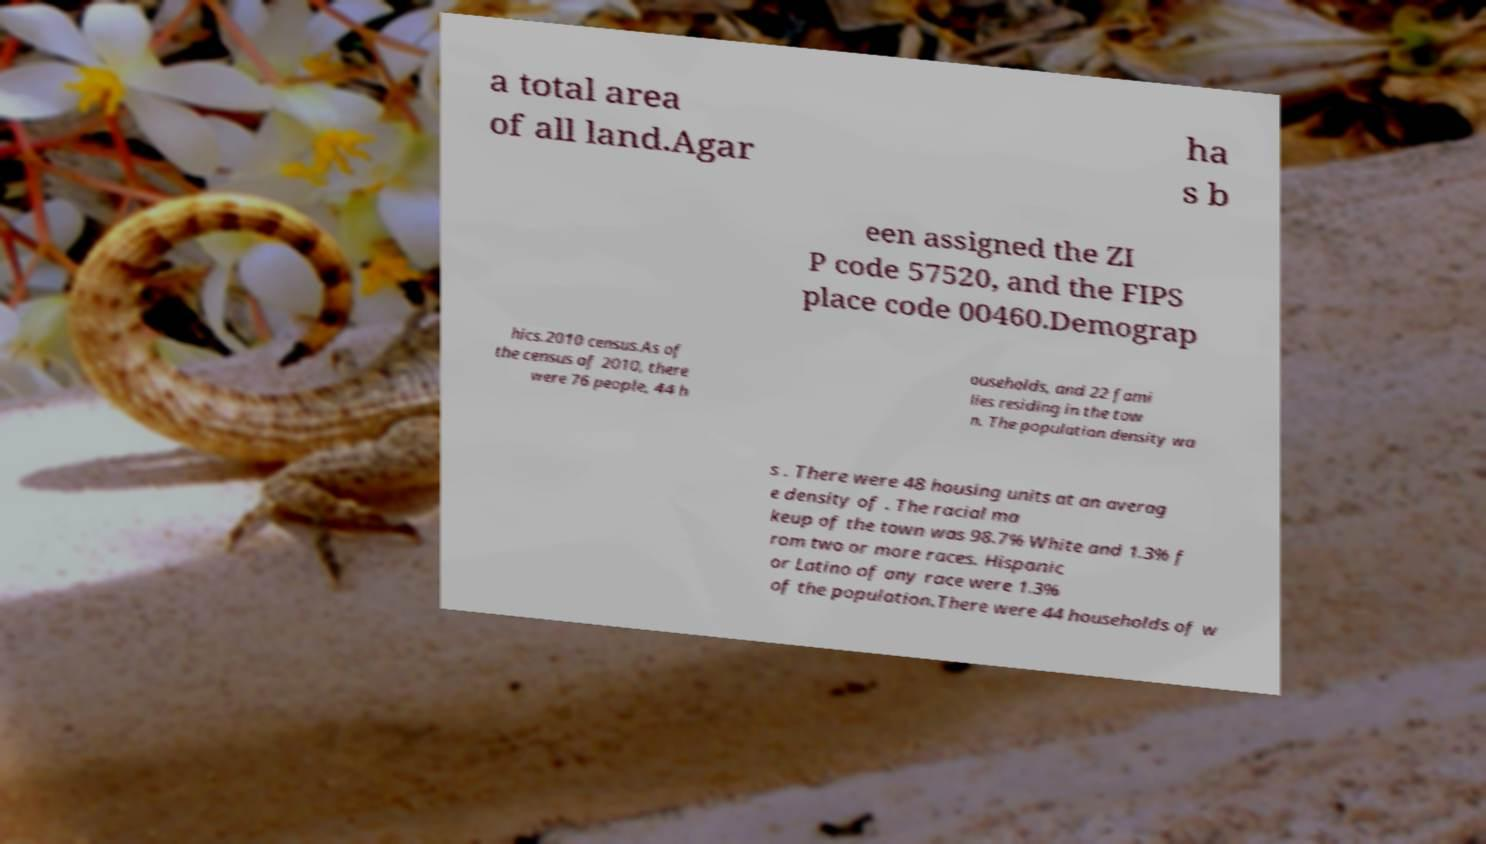Please read and relay the text visible in this image. What does it say? a total area of all land.Agar ha s b een assigned the ZI P code 57520, and the FIPS place code 00460.Demograp hics.2010 census.As of the census of 2010, there were 76 people, 44 h ouseholds, and 22 fami lies residing in the tow n. The population density wa s . There were 48 housing units at an averag e density of . The racial ma keup of the town was 98.7% White and 1.3% f rom two or more races. Hispanic or Latino of any race were 1.3% of the population.There were 44 households of w 